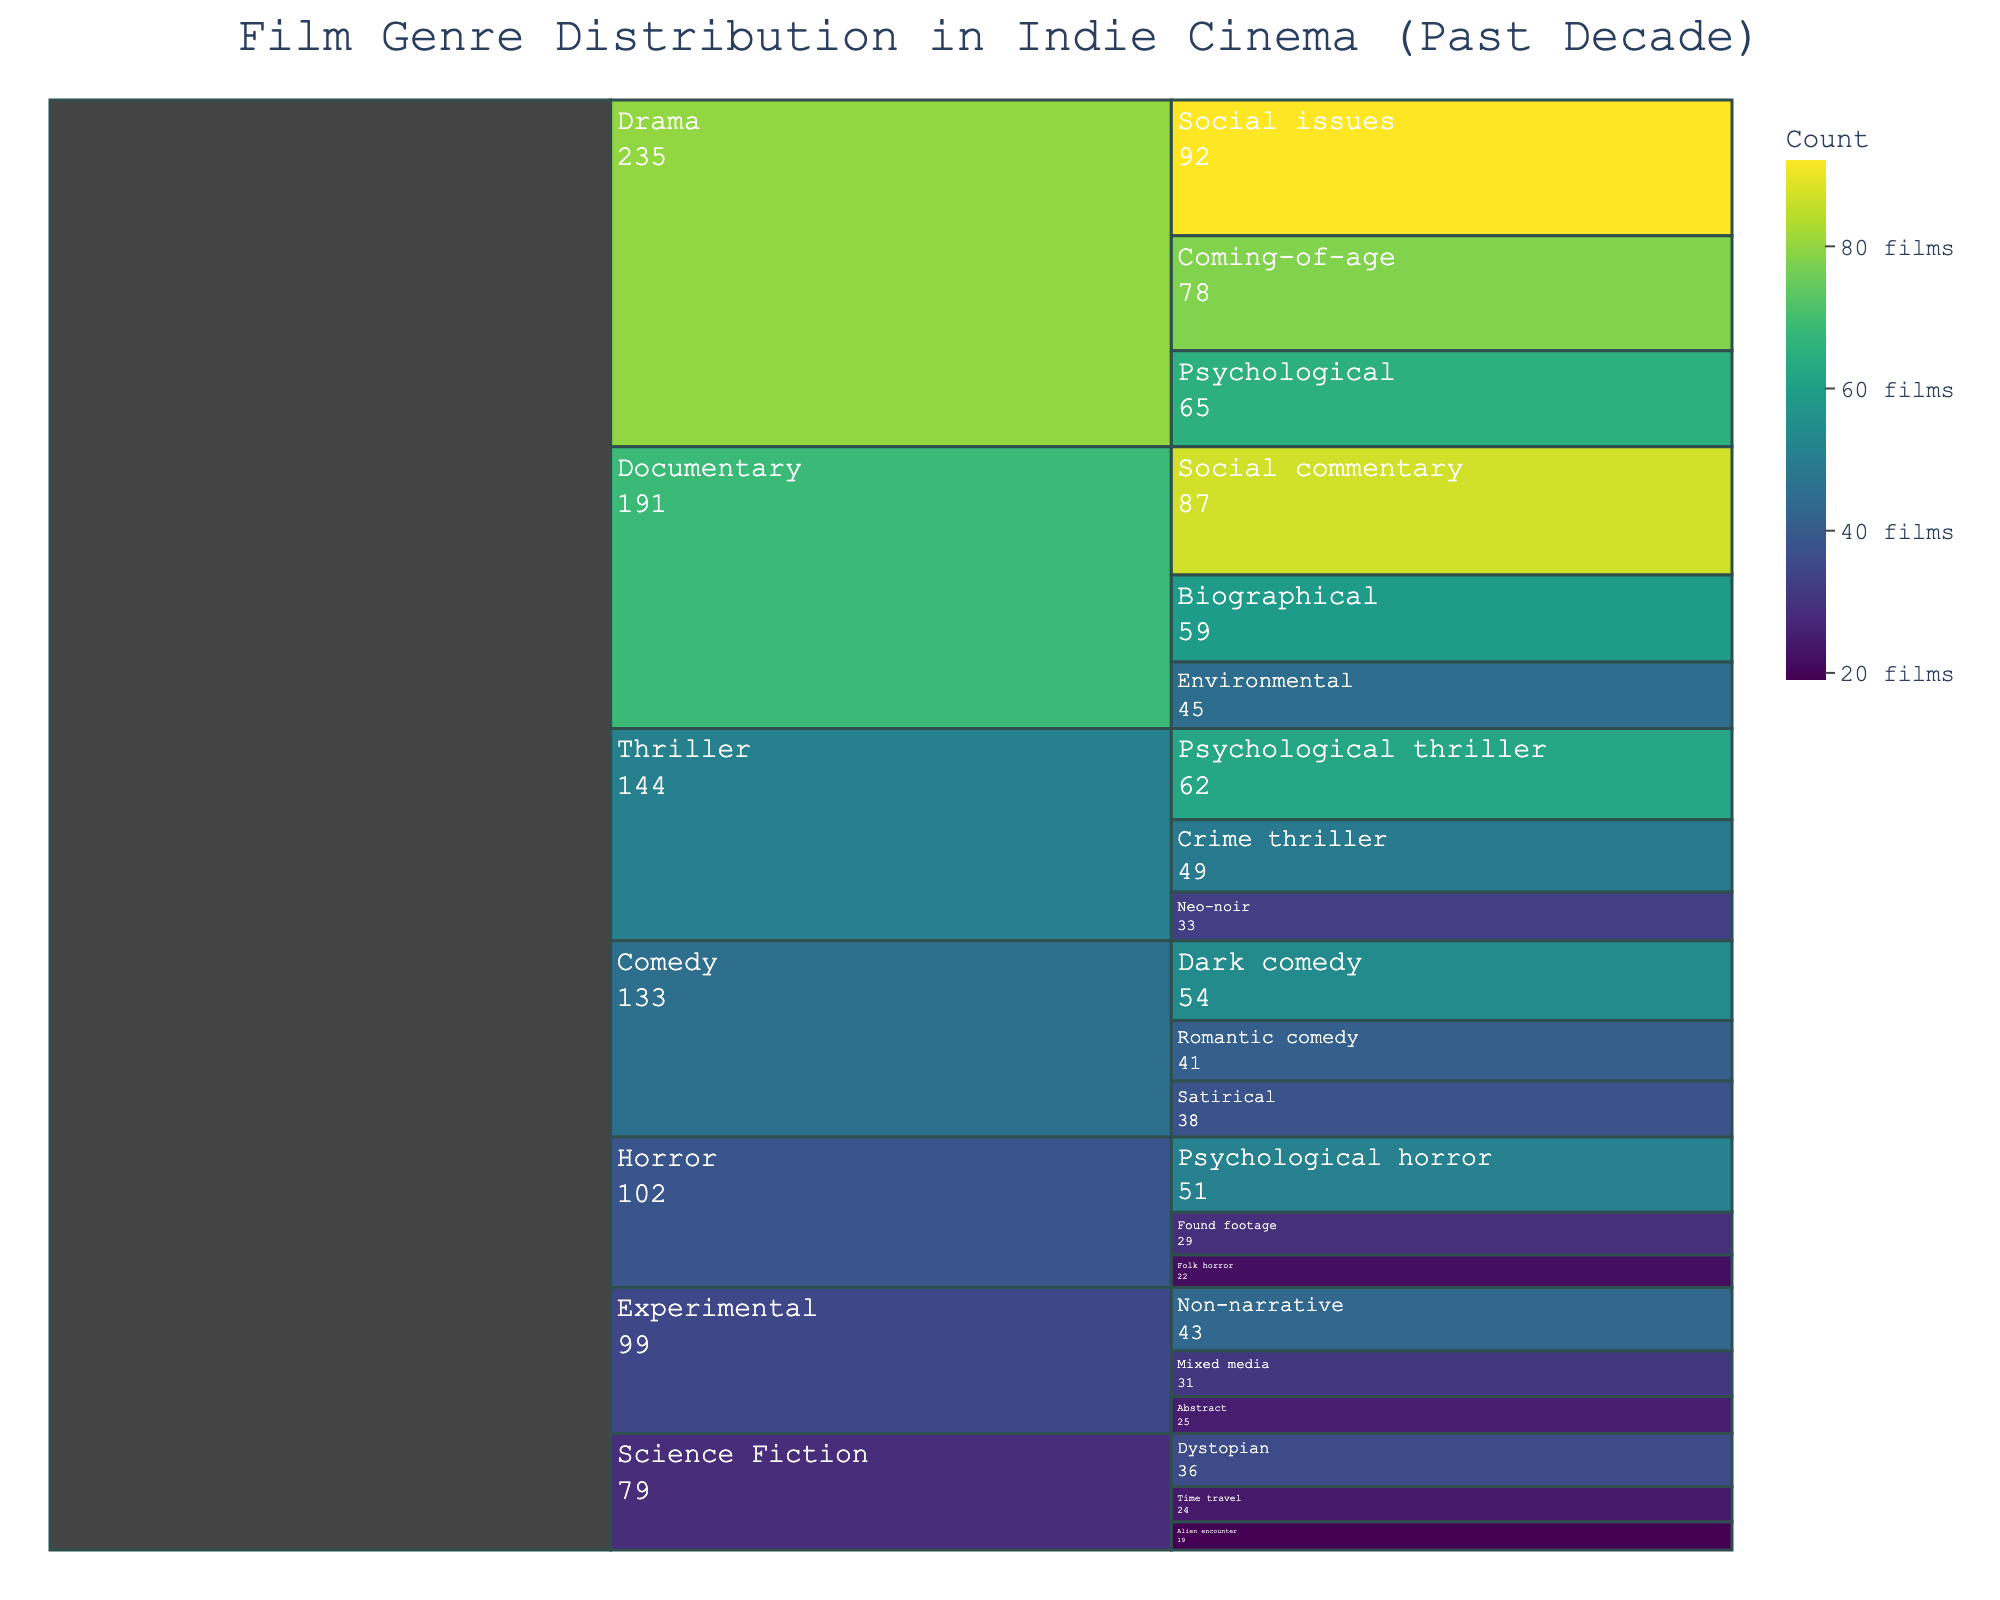What's the title of the figure? Look at the top of the chart, where the title is displayed.
Answer: Film Genre Distribution in Indie Cinema (Past Decade) Which genre has the highest count? Observe the chart to find the largest segment under the top level (genre).
Answer: Drama What's the total count of all Horror subgenres? Sum the values of all Horror subgenres which are Psychological horror: 51, Found footage: 29, Folk horror: 22. Total count is 51 + 29 + 22.
Answer: 102 Which subgenre under Documentary has the highest count? Compare the counts of the subgenres under Documentary: Social commentary, Biographical, Environmental. The highest count is Social commentary with 87.
Answer: Social commentary What is the difference in count between Psychological Thriller and Psychological Horror? Identify and subtract the counts: Psychological Thriller has 62, and Psychological Horror has 51. The difference is 62 - 51.
Answer: 11 Which genre has the least amount of subgenres? Count the subgenres for each genre and find the one with the fewest. Science Fiction has the least with three subgenres.
Answer: Science Fiction Compare the number of films in Dark comedy and Time travel subgenres. Which one has more films? Compare the counts of Dark comedy and Time travel. Dark comedy has 54 and Time travel has 24.
Answer: Dark comedy What is the combined count of all subgenres under Experimental? Sum the counts of the subgenres: Non-narrative: 43, Mixed media: 31, Abstract: 25. Total count is 43 + 31 + 25.
Answer: 99 How does the count of Romantic comedy compare to Abstract? Check the counts of Romantic comedy and Abstract. Romantic comedy has 41, Abstract has 25. Compare the two values.
Answer: Romantic comedy has more What's the percentage of films classified as Social issues under Drama out of all films in the Drama genre? Divide the count of Social issues by the total count in Drama: 92/(78 + 92 + 65), then multiply by 100. The calculation is 92/235 ≈ 0.3915, then 0.3915 * 100 ≈ 39.15%.
Answer: ~39.15% 